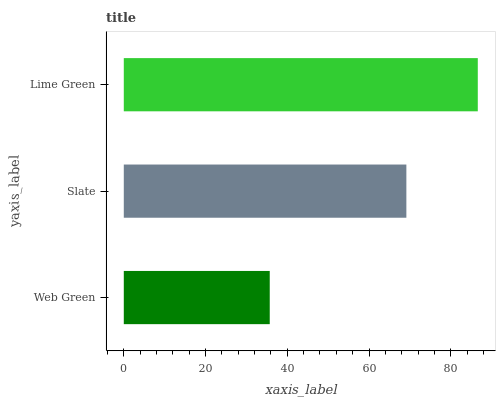Is Web Green the minimum?
Answer yes or no. Yes. Is Lime Green the maximum?
Answer yes or no. Yes. Is Slate the minimum?
Answer yes or no. No. Is Slate the maximum?
Answer yes or no. No. Is Slate greater than Web Green?
Answer yes or no. Yes. Is Web Green less than Slate?
Answer yes or no. Yes. Is Web Green greater than Slate?
Answer yes or no. No. Is Slate less than Web Green?
Answer yes or no. No. Is Slate the high median?
Answer yes or no. Yes. Is Slate the low median?
Answer yes or no. Yes. Is Web Green the high median?
Answer yes or no. No. Is Lime Green the low median?
Answer yes or no. No. 